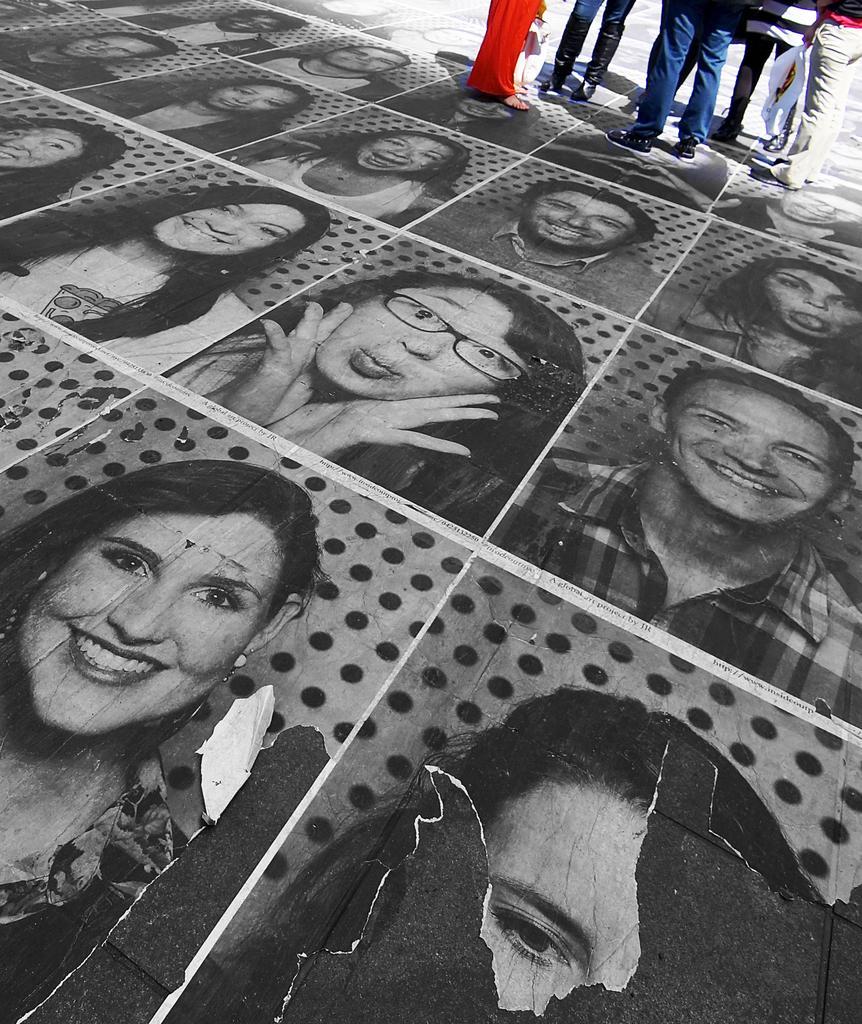Could you give a brief overview of what you see in this image? In this picture there is a collage floor in the center of the image, where we can see different types of photographs and there are people those who are standing at the top side of the image. 